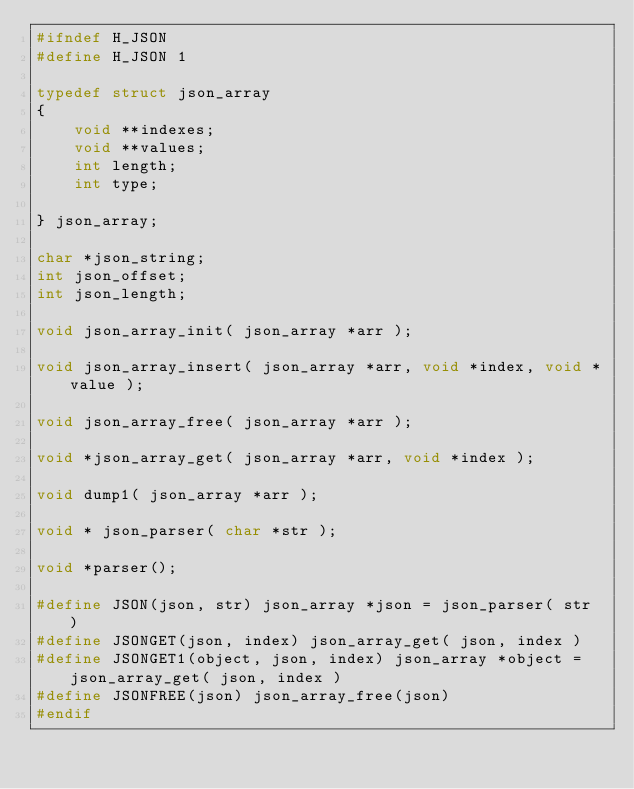<code> <loc_0><loc_0><loc_500><loc_500><_C_>#ifndef H_JSON
#define H_JSON 1

typedef struct json_array
{
	void **indexes; 
	void **values;
	int length;
	int type;

} json_array;

char *json_string;
int json_offset;
int json_length;

void json_array_init( json_array *arr );

void json_array_insert( json_array *arr, void *index, void *value );

void json_array_free( json_array *arr );

void *json_array_get( json_array *arr, void *index );

void dump1( json_array *arr );

void * json_parser( char *str );

void *parser();

#define JSON(json, str) json_array *json = json_parser( str )
#define JSONGET(json, index) json_array_get( json, index )
#define JSONGET1(object, json, index) json_array *object = json_array_get( json, index )
#define JSONFREE(json) json_array_free(json)
#endif</code> 